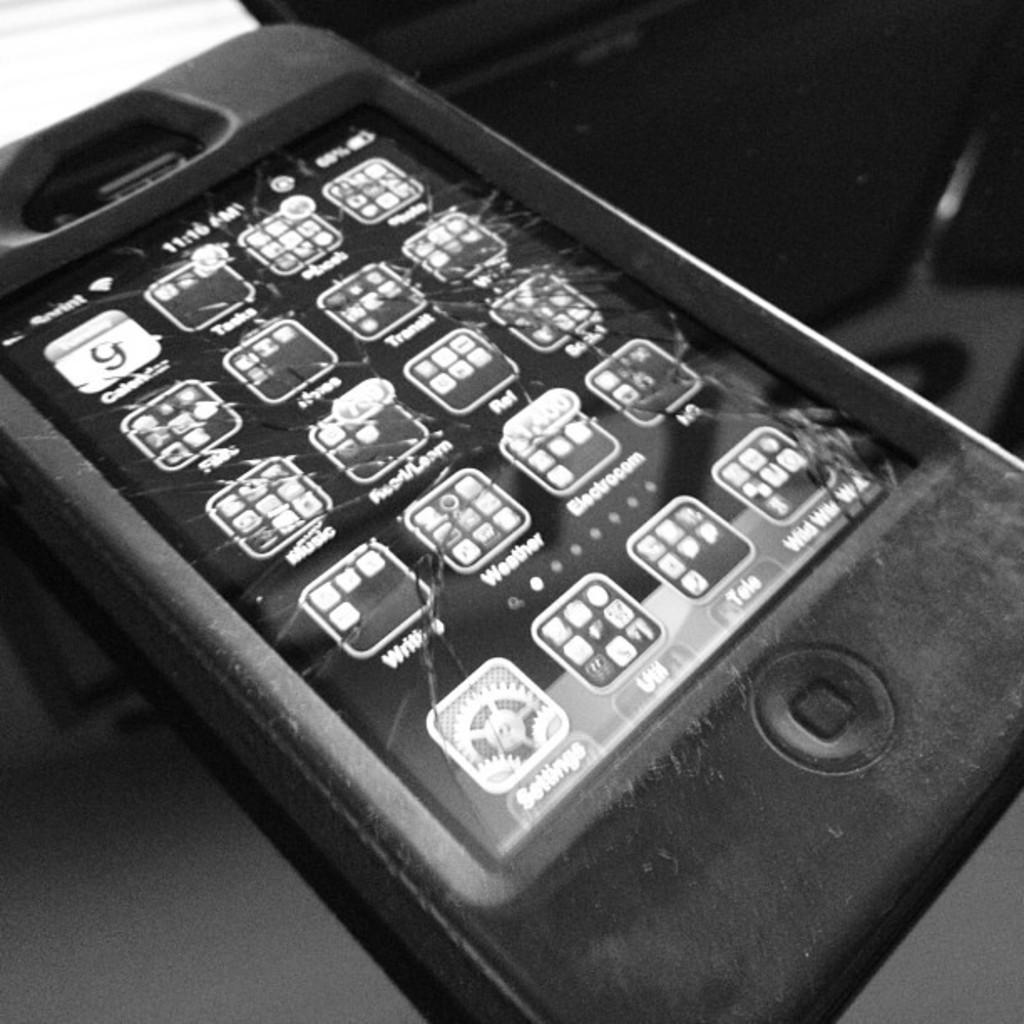What time on the phone?
Offer a very short reply. 11:16. What is the app on the bottom left?
Offer a very short reply. Settings. 